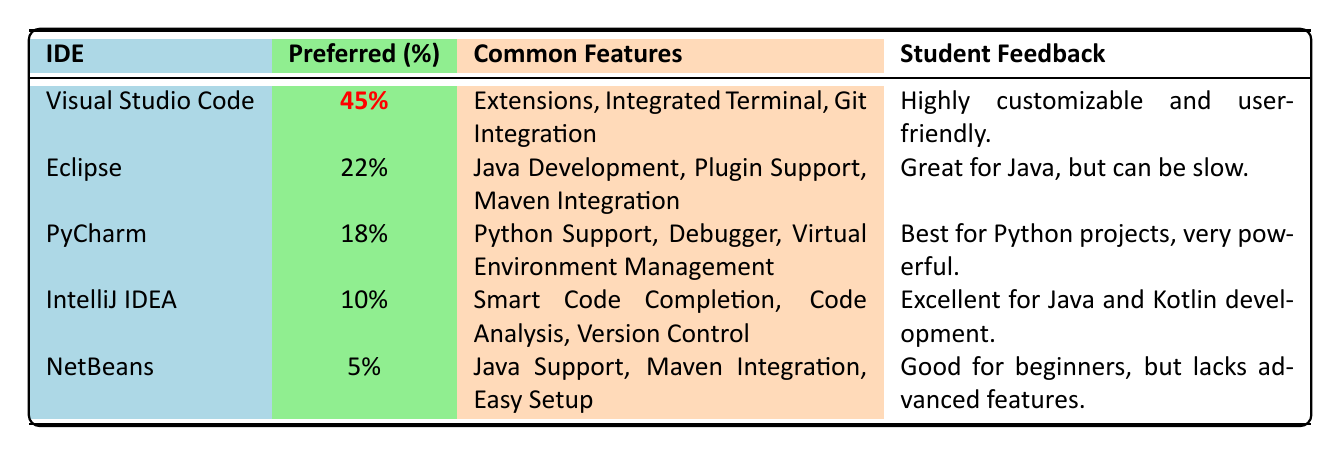What IDE is preferred by the highest percentage of students? The table shows the preferred percentage for each IDE. Visual Studio Code has a highlighted value of 45%, which is the highest among all listed IDEs.
Answer: Visual Studio Code How many percent of students prefer Eclipse? The table lists Eclipse with a preferred percentage of 22%. This value can be found directly in the corresponding row for Eclipse.
Answer: 22% What are the common features of PyCharm? According to the table, PyCharm has the common features of Python Support, Debugger, and Virtual Environment Management. This information is directly listed under the common features column for PyCharm.
Answer: Python Support, Debugger, Virtual Environment Management Which IDE has the least preferred percentage and what is it? The table indicates that NetBeans has the least preferred percentage, which is 5%. We can determine this by comparing the preferred percentages for all IDEs and identifying the lowest value.
Answer: NetBeans, 5% What is the difference in preferred percentage between Visual Studio Code and IntelliJ IDEA? The preferred percentage for Visual Studio Code is 45%, and for IntelliJ IDEA, it is 10%. The difference can be calculated as 45% - 10% = 35%.
Answer: 35% Are there more students who prefer PyCharm than IntelliJ IDEA? The preferred percentage for PyCharm is 18%, while for IntelliJ IDEA it is 10%. Since 18% is greater than 10%, we conclude that more students prefer PyCharm.
Answer: Yes What is the total preferred percentage of all the IDEs listed in the table? We sum the preferred percentages: 45% + 22% + 18% + 10% + 5% = 100%. By adding together all the percentages, we find that they total 100%.
Answer: 100% Considering the student feedback, which IDE is highlighted as being user-friendly? The feedback for Visual Studio Code states it is "Highly customizable and user-friendly," while no other IDE feedback directly mentions user-friendliness. Therefore, it is the only one highlighted in that regard.
Answer: Visual Studio Code How does the preference for Eclipse compare to the combined preference of NetBeans and IntelliJ IDEA? Comparing Eclipse's preference of 22% with the combined preference of NetBeans (5%) and IntelliJ IDEA (10%) gives us a total of 15%. Since 22% (Eclipse) is greater than 15% (NetBeans + IntelliJ IDEA), we conclude that Eclipse is preferred more.
Answer: Eclipse is preferred more What percentage of students prefer IDEs that support Java programming? Eclipse (22%), IntelliJ IDEA (10%), and NetBeans (5%) all support Java programming. We sum these percentages: 22% + 10% + 5% = 37%. This total percentage reflects those who prefer Java-supporting IDEs.
Answer: 37% 